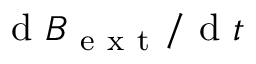Convert formula to latex. <formula><loc_0><loc_0><loc_500><loc_500>d { B } _ { e x t } / d { t }</formula> 